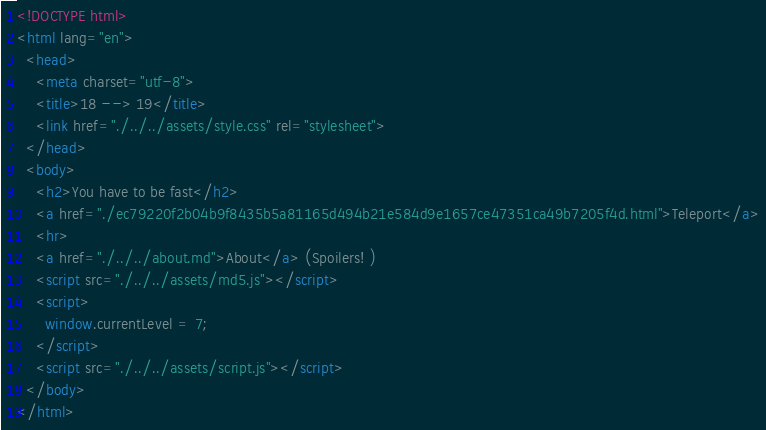<code> <loc_0><loc_0><loc_500><loc_500><_HTML_><!DOCTYPE html>
<html lang="en">
  <head>
    <meta charset="utf-8">
    <title>18 --> 19</title>
    <link href="./../../assets/style.css" rel="stylesheet">
  </head>
  <body>
    <h2>You have to be fast</h2>
    <a href="./ec79220f2b04b9f8435b5a81165d494b21e584d9e1657ce47351ca49b7205f4d.html">Teleport</a>
    <hr>
    <a href="./../../about.md">About</a> (Spoilers! )
    <script src="./../../assets/md5.js"></script>
    <script>
      window.currentLevel = 7;
    </script>
    <script src="./../../assets/script.js"></script>
  </body>
</html></code> 